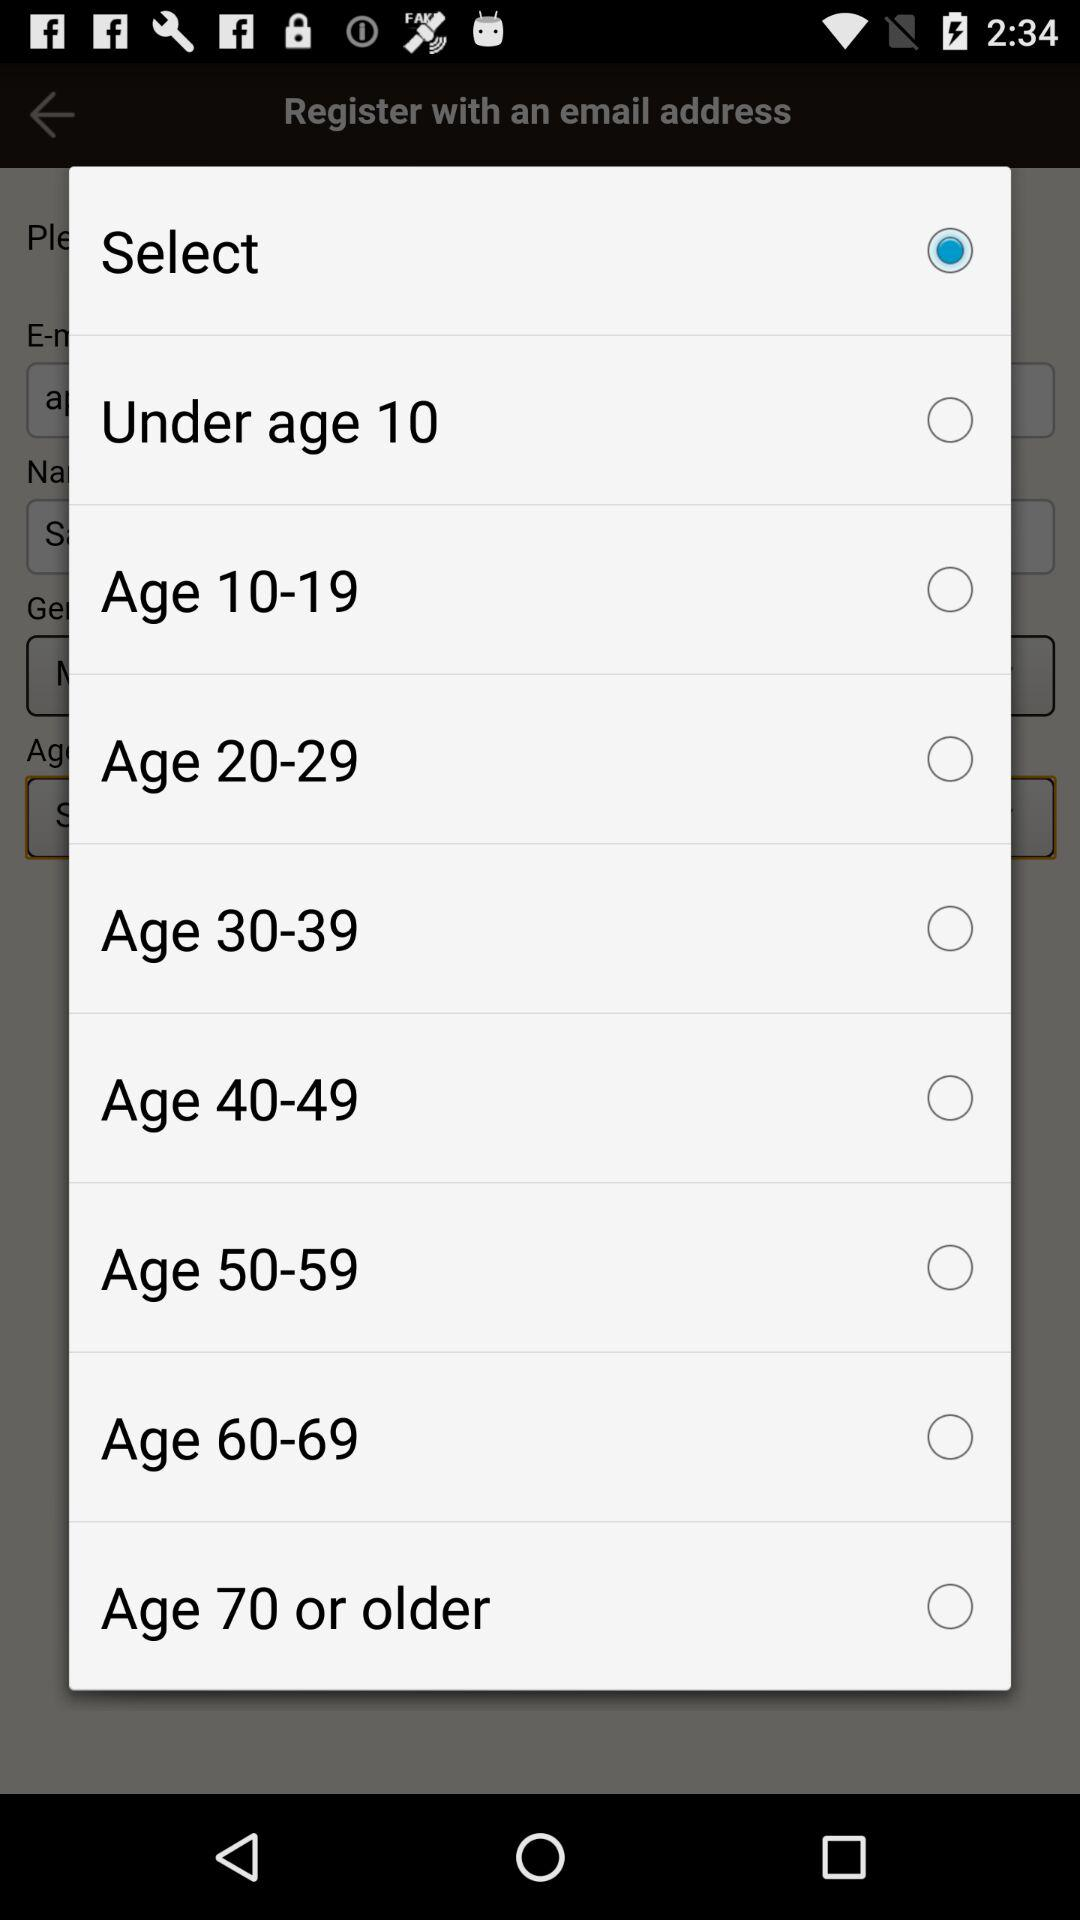What is the status of "Under age 10"? The status is "off". 